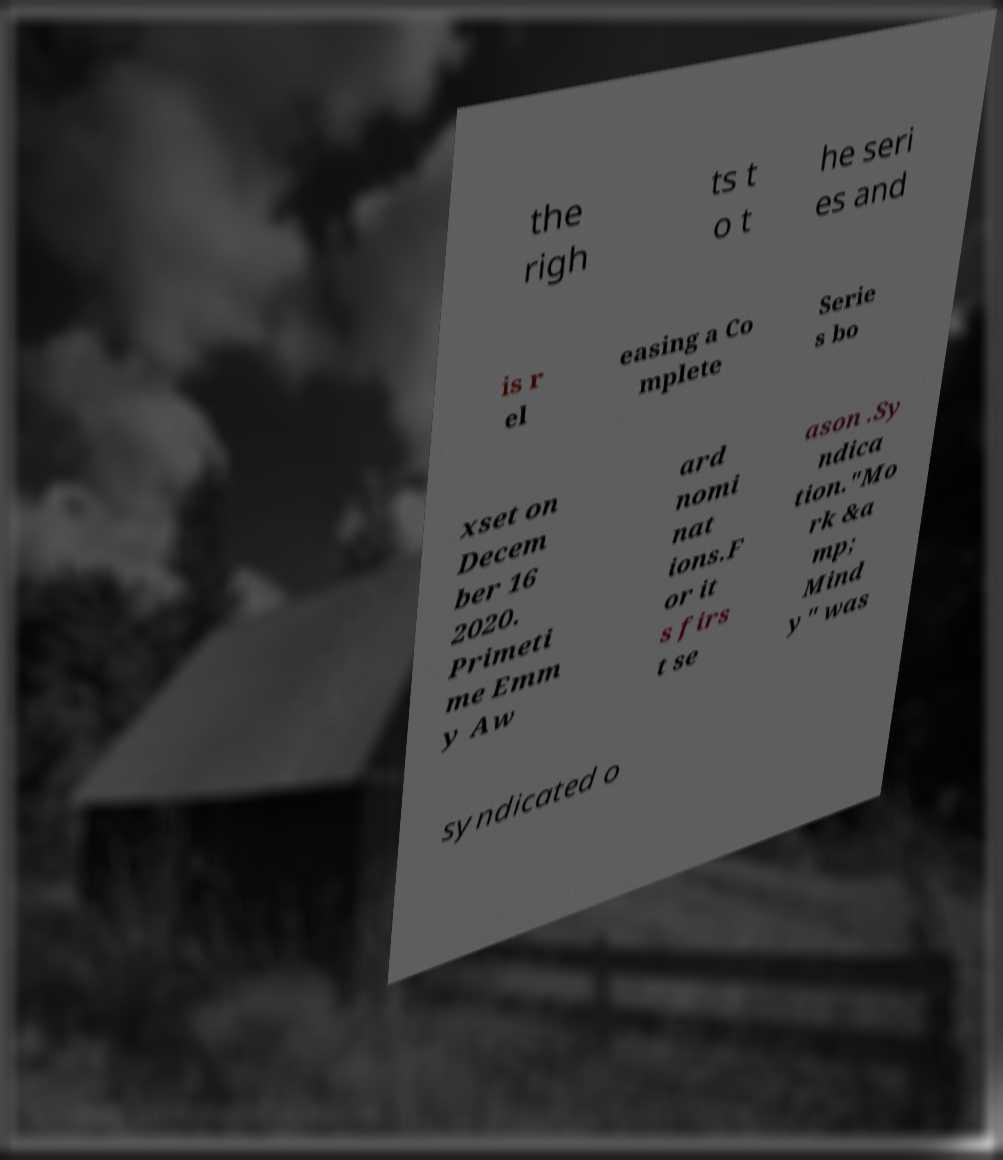For documentation purposes, I need the text within this image transcribed. Could you provide that? the righ ts t o t he seri es and is r el easing a Co mplete Serie s bo xset on Decem ber 16 2020. Primeti me Emm y Aw ard nomi nat ions.F or it s firs t se ason .Sy ndica tion."Mo rk &a mp; Mind y" was syndicated o 